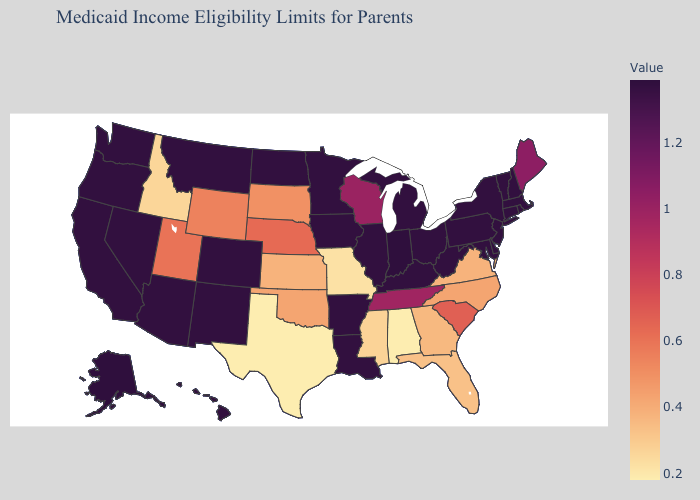Among the states that border Illinois , does Missouri have the lowest value?
Keep it brief. Yes. Among the states that border Virginia , which have the highest value?
Be succinct. Kentucky, Maryland, West Virginia. Which states have the highest value in the USA?
Write a very short answer. Alaska, Indiana. Which states have the highest value in the USA?
Give a very brief answer. Alaska, Indiana. Does New York have the lowest value in the Northeast?
Keep it brief. No. 